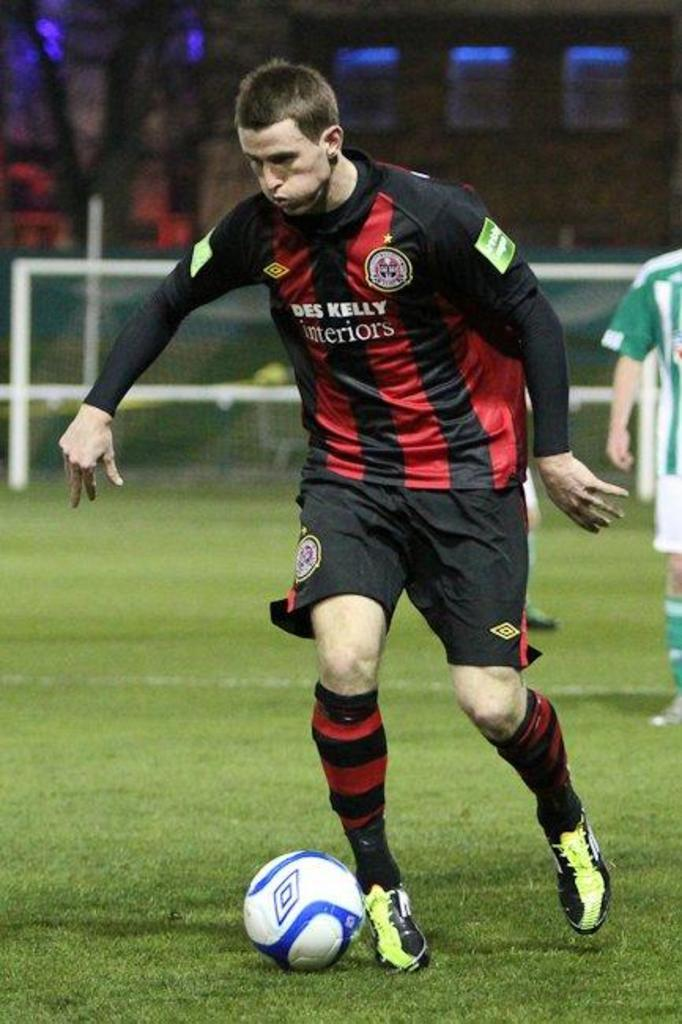What is the main subject of the image? The main subject of the image is a football ground. What is the man in the image doing? The man is kicking a football in the ground. What can be seen in the background of the image? There is a pole in the background of the image. What type of throne is the minister sitting on in the image? There is no minister or throne present in the image; it features a football ground and a man kicking a football. 